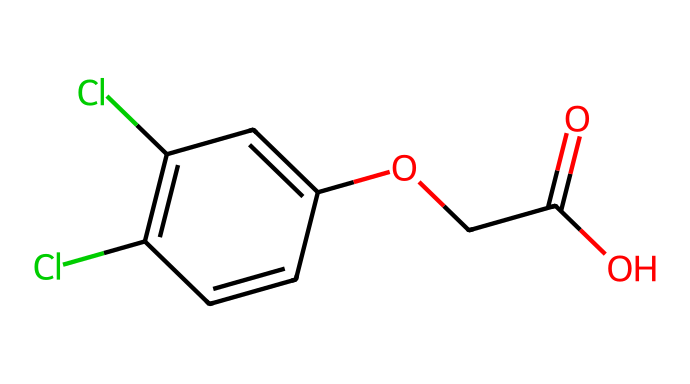What is the total number of carbon atoms in 2,4-Dichlorophenoxyacetic acid? By analyzing the SMILES representation, the structure contains 8 carbon atoms as seen in the chain and ring structure.
Answer: 8 What functional group is present in 2,4-Dichlorophenoxyacetic acid that indicates it is a herbicide? The presence of the carboxylic acid group, represented by "C(=O)O" in the SMILES, indicates it has herbicidal properties.
Answer: carboxylic acid How many chlorine atoms are attached to the benzene ring in this herbicide? The SMILES indicates there are two "Cl" groups attached to the benzene ring as seen in "C1=C(Cl)C=C(Cl)C=C1."
Answer: 2 What type of bonding characterizes the connection between the phenoxy and acetic acid moiety? The ether bond characterizes the connection, as the structure includes the "O" in "OCC(=O)O" linking the phenolic part to the acetic acid part.
Answer: ether bond What is the significance of the hydroxyl (-OH) group in the structure of 2,4-Dichlorophenoxyacetic acid? The hydroxyl group contributes to the acid's water solubility and is involved in its biological activity as a herbicide.
Answer: water solubility How does the structure of 2,4-Dichlorophenoxyacetic acid contribute to its function as a selective herbicide? The herbicide's structure, including the phenoxy moiety and specific substituents, allows it to mimic plant hormones, disrupting growth in broadleaf plants while being less harmful to grass species.
Answer: selective herbicide functions 